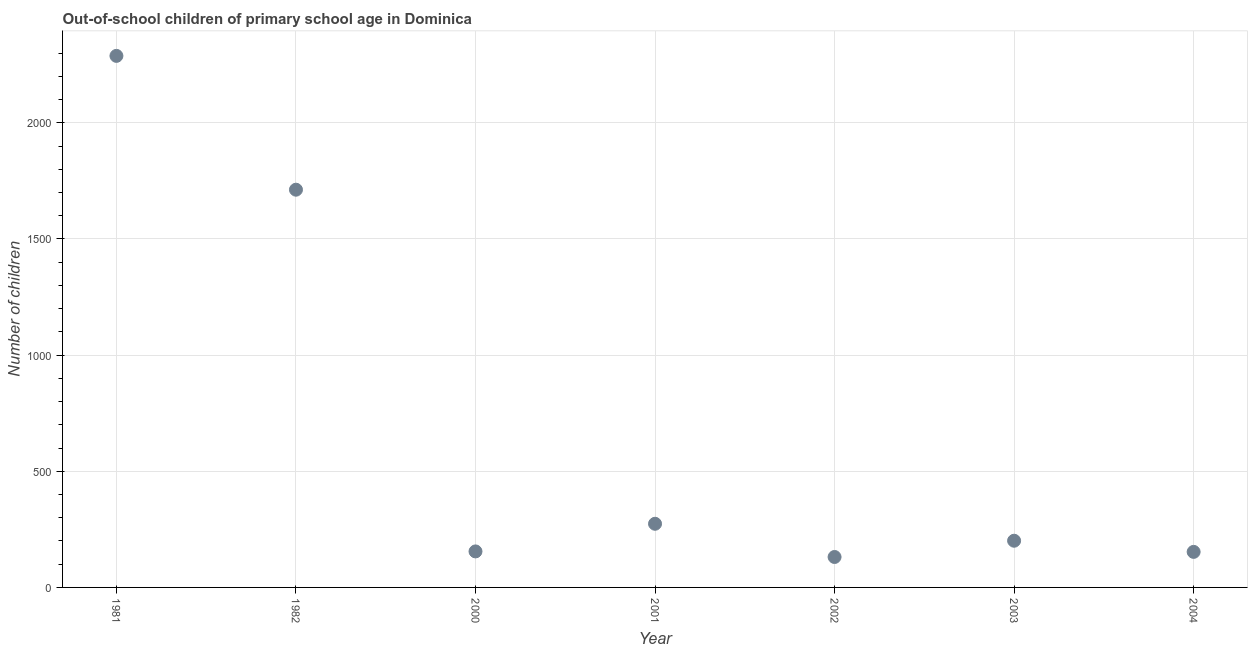What is the number of out-of-school children in 1982?
Offer a very short reply. 1712. Across all years, what is the maximum number of out-of-school children?
Offer a terse response. 2288. Across all years, what is the minimum number of out-of-school children?
Your answer should be very brief. 131. What is the sum of the number of out-of-school children?
Provide a short and direct response. 4914. What is the difference between the number of out-of-school children in 2001 and 2002?
Provide a succinct answer. 143. What is the average number of out-of-school children per year?
Provide a short and direct response. 702. What is the median number of out-of-school children?
Give a very brief answer. 201. In how many years, is the number of out-of-school children greater than 1700 ?
Your answer should be very brief. 2. What is the ratio of the number of out-of-school children in 1981 to that in 2003?
Offer a very short reply. 11.38. Is the number of out-of-school children in 1981 less than that in 1982?
Provide a succinct answer. No. What is the difference between the highest and the second highest number of out-of-school children?
Ensure brevity in your answer.  576. What is the difference between the highest and the lowest number of out-of-school children?
Your answer should be very brief. 2157. In how many years, is the number of out-of-school children greater than the average number of out-of-school children taken over all years?
Your response must be concise. 2. Does the number of out-of-school children monotonically increase over the years?
Provide a succinct answer. No. How many dotlines are there?
Keep it short and to the point. 1. How many years are there in the graph?
Offer a very short reply. 7. Does the graph contain grids?
Your response must be concise. Yes. What is the title of the graph?
Keep it short and to the point. Out-of-school children of primary school age in Dominica. What is the label or title of the Y-axis?
Your answer should be compact. Number of children. What is the Number of children in 1981?
Your answer should be very brief. 2288. What is the Number of children in 1982?
Provide a succinct answer. 1712. What is the Number of children in 2000?
Give a very brief answer. 155. What is the Number of children in 2001?
Provide a succinct answer. 274. What is the Number of children in 2002?
Your answer should be compact. 131. What is the Number of children in 2003?
Make the answer very short. 201. What is the Number of children in 2004?
Your answer should be very brief. 153. What is the difference between the Number of children in 1981 and 1982?
Provide a short and direct response. 576. What is the difference between the Number of children in 1981 and 2000?
Provide a succinct answer. 2133. What is the difference between the Number of children in 1981 and 2001?
Offer a very short reply. 2014. What is the difference between the Number of children in 1981 and 2002?
Offer a very short reply. 2157. What is the difference between the Number of children in 1981 and 2003?
Offer a terse response. 2087. What is the difference between the Number of children in 1981 and 2004?
Make the answer very short. 2135. What is the difference between the Number of children in 1982 and 2000?
Your answer should be compact. 1557. What is the difference between the Number of children in 1982 and 2001?
Ensure brevity in your answer.  1438. What is the difference between the Number of children in 1982 and 2002?
Your answer should be compact. 1581. What is the difference between the Number of children in 1982 and 2003?
Offer a very short reply. 1511. What is the difference between the Number of children in 1982 and 2004?
Make the answer very short. 1559. What is the difference between the Number of children in 2000 and 2001?
Offer a terse response. -119. What is the difference between the Number of children in 2000 and 2002?
Give a very brief answer. 24. What is the difference between the Number of children in 2000 and 2003?
Provide a succinct answer. -46. What is the difference between the Number of children in 2001 and 2002?
Make the answer very short. 143. What is the difference between the Number of children in 2001 and 2003?
Your answer should be very brief. 73. What is the difference between the Number of children in 2001 and 2004?
Provide a short and direct response. 121. What is the difference between the Number of children in 2002 and 2003?
Offer a terse response. -70. What is the difference between the Number of children in 2003 and 2004?
Your answer should be very brief. 48. What is the ratio of the Number of children in 1981 to that in 1982?
Provide a succinct answer. 1.34. What is the ratio of the Number of children in 1981 to that in 2000?
Your answer should be compact. 14.76. What is the ratio of the Number of children in 1981 to that in 2001?
Give a very brief answer. 8.35. What is the ratio of the Number of children in 1981 to that in 2002?
Offer a very short reply. 17.47. What is the ratio of the Number of children in 1981 to that in 2003?
Ensure brevity in your answer.  11.38. What is the ratio of the Number of children in 1981 to that in 2004?
Ensure brevity in your answer.  14.95. What is the ratio of the Number of children in 1982 to that in 2000?
Provide a short and direct response. 11.04. What is the ratio of the Number of children in 1982 to that in 2001?
Your response must be concise. 6.25. What is the ratio of the Number of children in 1982 to that in 2002?
Ensure brevity in your answer.  13.07. What is the ratio of the Number of children in 1982 to that in 2003?
Offer a very short reply. 8.52. What is the ratio of the Number of children in 1982 to that in 2004?
Your response must be concise. 11.19. What is the ratio of the Number of children in 2000 to that in 2001?
Offer a terse response. 0.57. What is the ratio of the Number of children in 2000 to that in 2002?
Your answer should be compact. 1.18. What is the ratio of the Number of children in 2000 to that in 2003?
Provide a short and direct response. 0.77. What is the ratio of the Number of children in 2001 to that in 2002?
Provide a short and direct response. 2.09. What is the ratio of the Number of children in 2001 to that in 2003?
Make the answer very short. 1.36. What is the ratio of the Number of children in 2001 to that in 2004?
Give a very brief answer. 1.79. What is the ratio of the Number of children in 2002 to that in 2003?
Offer a terse response. 0.65. What is the ratio of the Number of children in 2002 to that in 2004?
Ensure brevity in your answer.  0.86. What is the ratio of the Number of children in 2003 to that in 2004?
Your answer should be very brief. 1.31. 